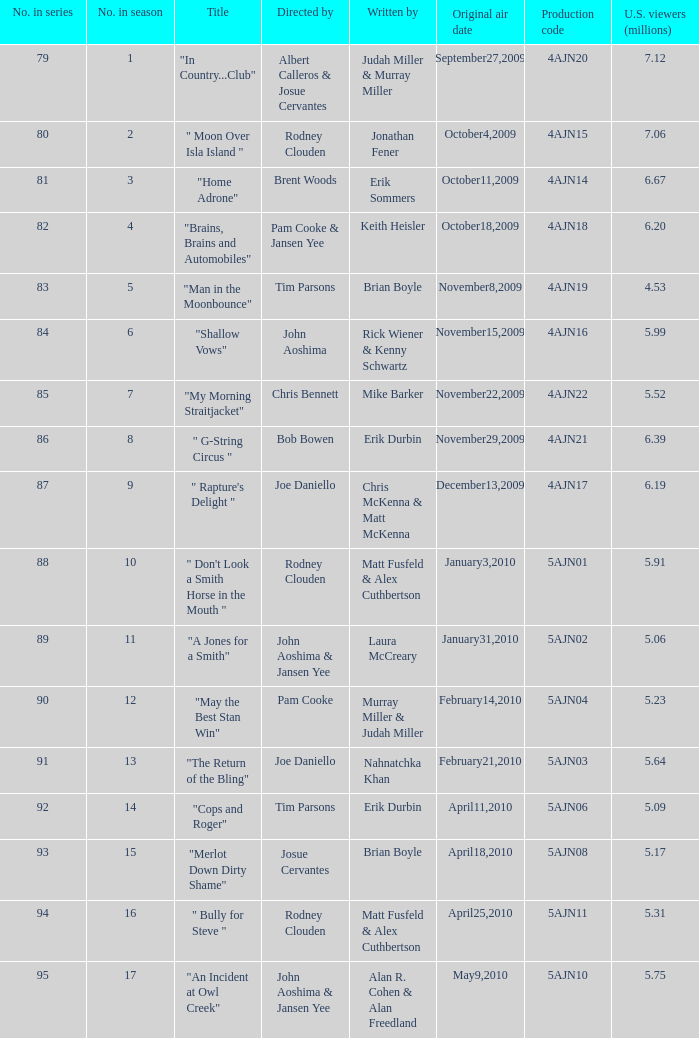Name who wrote the episode directed by  pam cooke & jansen yee Keith Heisler. 